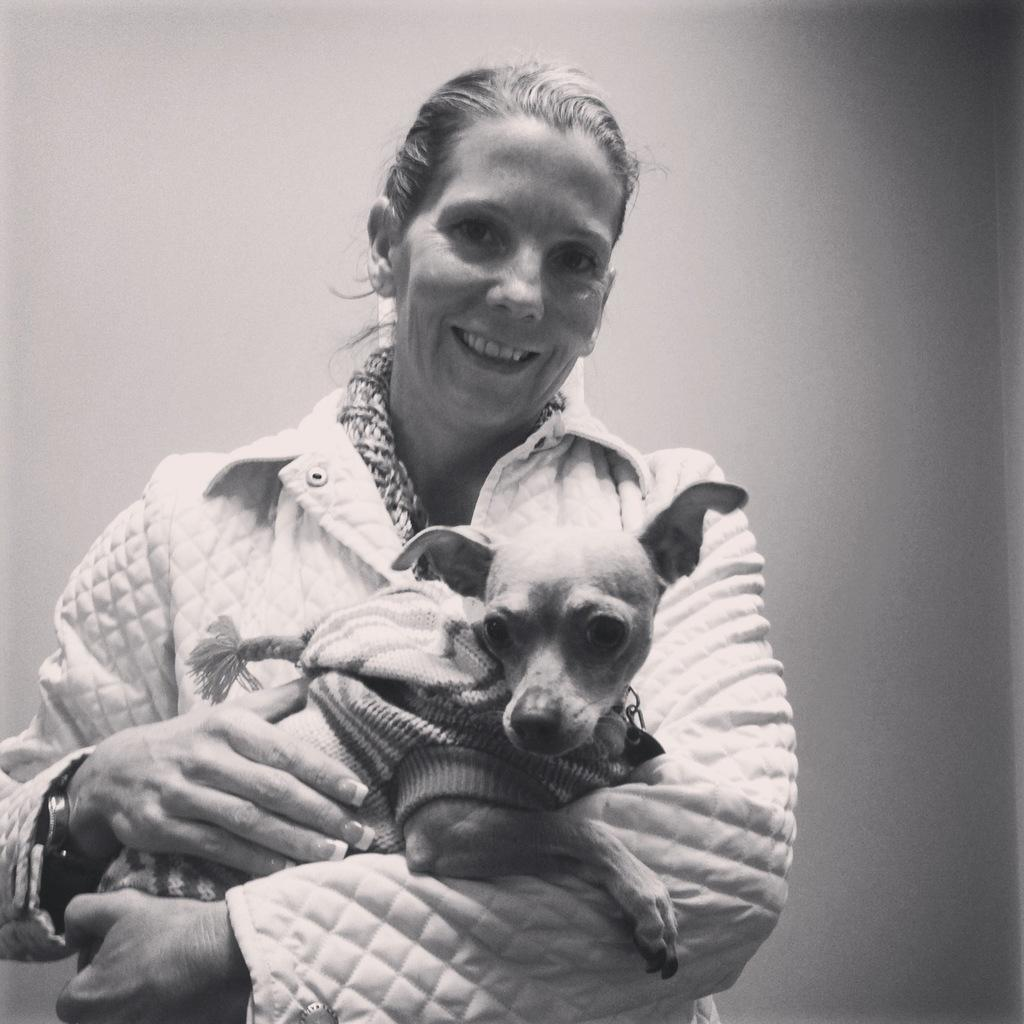What is the image is in which color scheme? The image is black and white. Who is present in the image? There is a woman in the image. What is the woman wearing? The woman is wearing a white coat. What is the woman holding in the image? The woman is holding a dog. What can be seen in the background of the image? There is a wall in the background of the image. What type of rifle can be seen in the image? There is no rifle present in the image. 